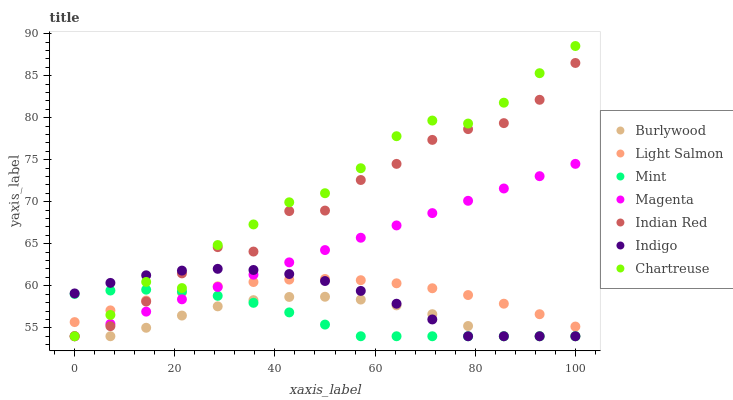Does Mint have the minimum area under the curve?
Answer yes or no. Yes. Does Chartreuse have the maximum area under the curve?
Answer yes or no. Yes. Does Indigo have the minimum area under the curve?
Answer yes or no. No. Does Indigo have the maximum area under the curve?
Answer yes or no. No. Is Magenta the smoothest?
Answer yes or no. Yes. Is Indian Red the roughest?
Answer yes or no. Yes. Is Indigo the smoothest?
Answer yes or no. No. Is Indigo the roughest?
Answer yes or no. No. Does Indigo have the lowest value?
Answer yes or no. Yes. Does Chartreuse have the highest value?
Answer yes or no. Yes. Does Indigo have the highest value?
Answer yes or no. No. Is Burlywood less than Light Salmon?
Answer yes or no. Yes. Is Light Salmon greater than Burlywood?
Answer yes or no. Yes. Does Mint intersect Magenta?
Answer yes or no. Yes. Is Mint less than Magenta?
Answer yes or no. No. Is Mint greater than Magenta?
Answer yes or no. No. Does Burlywood intersect Light Salmon?
Answer yes or no. No. 